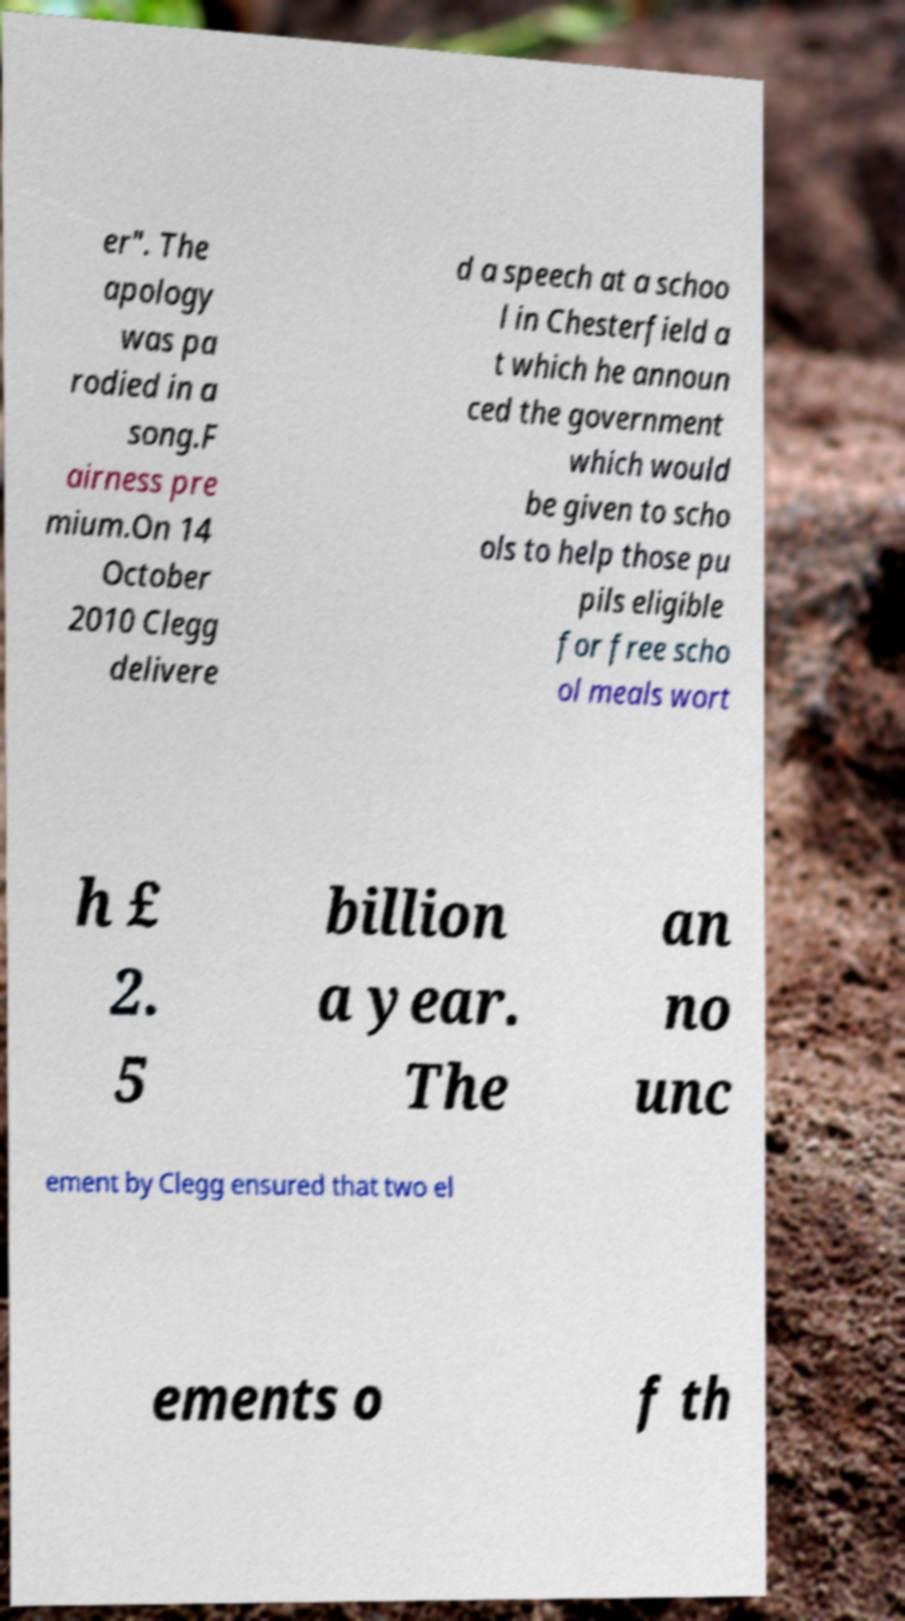Please identify and transcribe the text found in this image. er". The apology was pa rodied in a song.F airness pre mium.On 14 October 2010 Clegg delivere d a speech at a schoo l in Chesterfield a t which he announ ced the government which would be given to scho ols to help those pu pils eligible for free scho ol meals wort h £ 2. 5 billion a year. The an no unc ement by Clegg ensured that two el ements o f th 